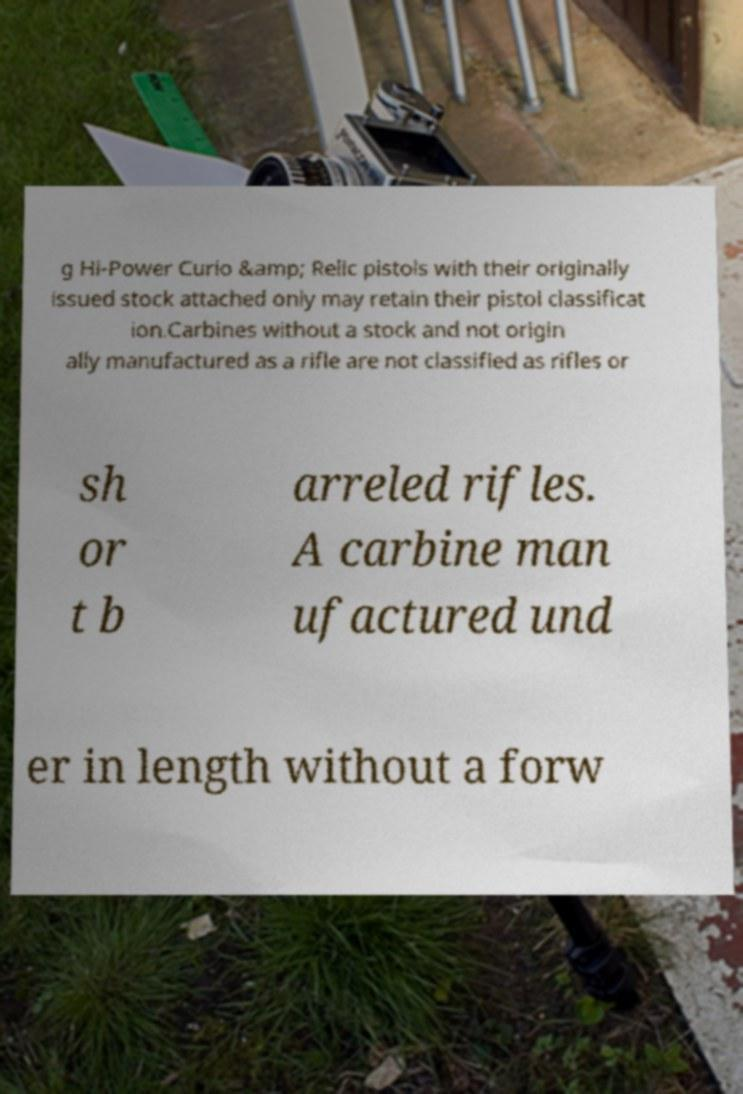Can you read and provide the text displayed in the image?This photo seems to have some interesting text. Can you extract and type it out for me? g Hi-Power Curio &amp; Relic pistols with their originally issued stock attached only may retain their pistol classificat ion.Carbines without a stock and not origin ally manufactured as a rifle are not classified as rifles or sh or t b arreled rifles. A carbine man ufactured und er in length without a forw 